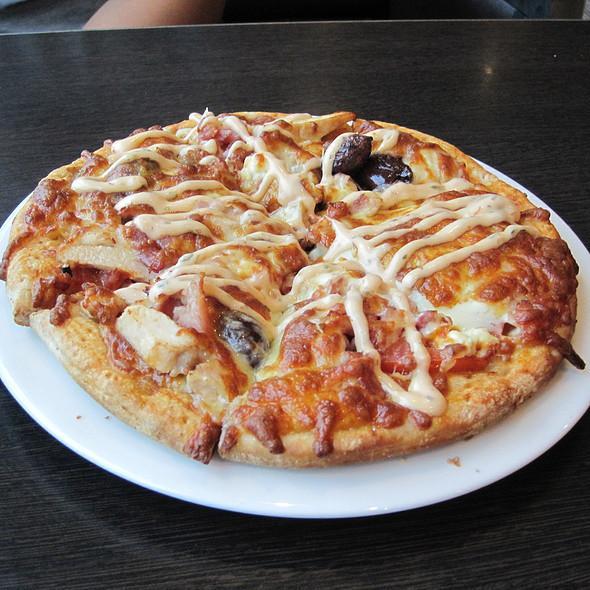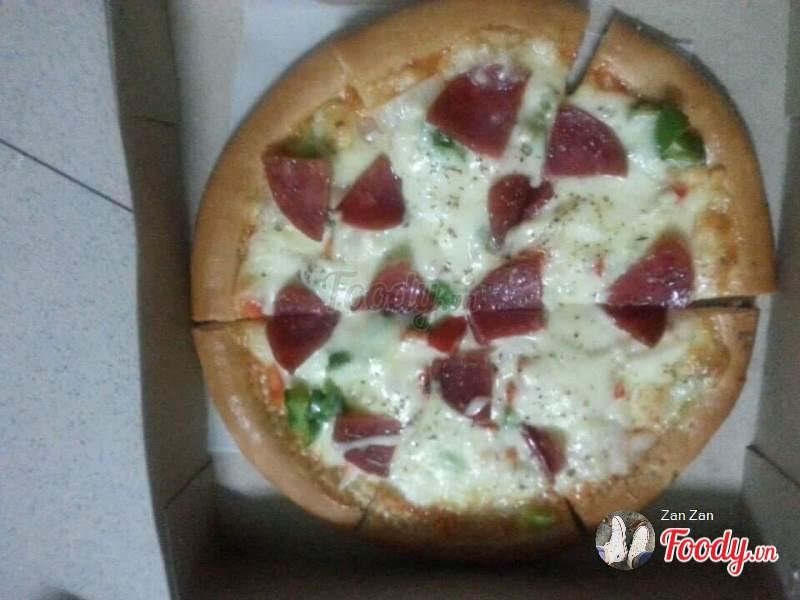The first image is the image on the left, the second image is the image on the right. Evaluate the accuracy of this statement regarding the images: "The pizza on the left has citrus on top.". Is it true? Answer yes or no. No. The first image is the image on the left, the second image is the image on the right. Given the left and right images, does the statement "There is at least one lemon on top of the pizza." hold true? Answer yes or no. No. 